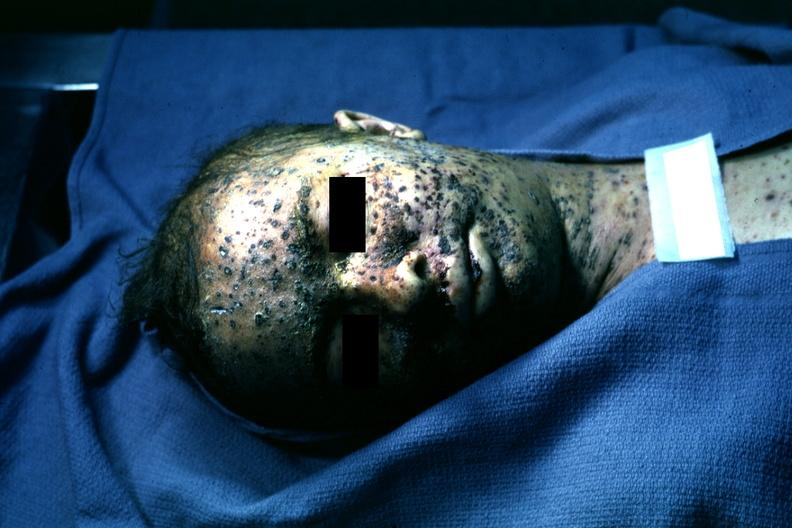does papillary adenoma show extensive lesions?
Answer the question using a single word or phrase. No 